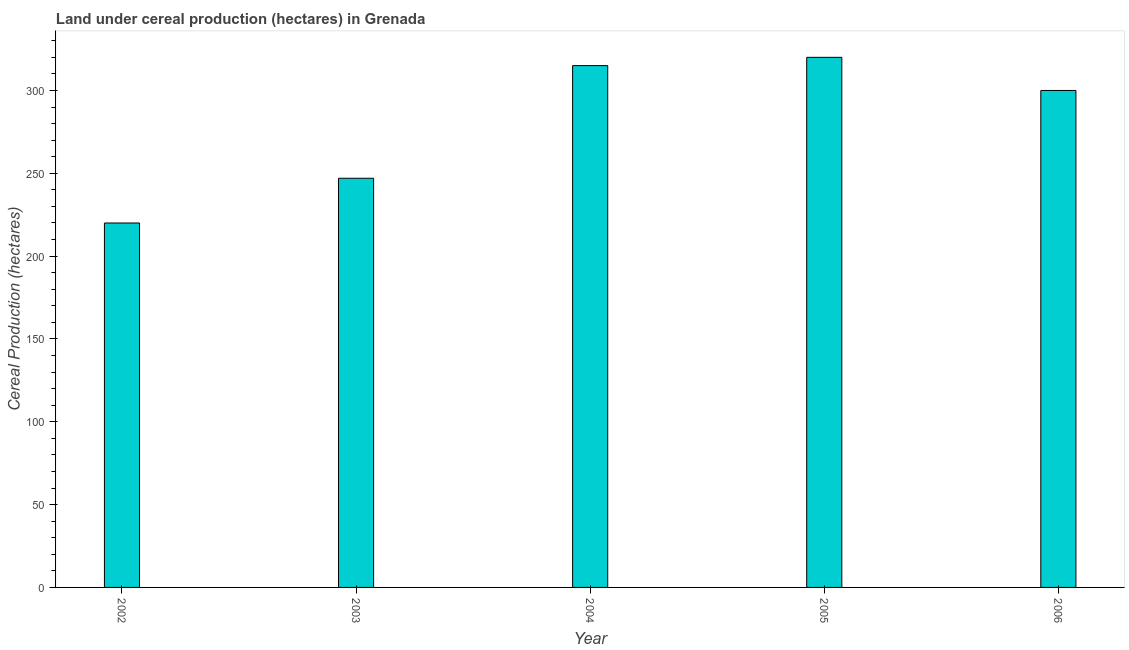Does the graph contain any zero values?
Offer a very short reply. No. What is the title of the graph?
Make the answer very short. Land under cereal production (hectares) in Grenada. What is the label or title of the Y-axis?
Provide a short and direct response. Cereal Production (hectares). What is the land under cereal production in 2006?
Provide a short and direct response. 300. Across all years, what is the maximum land under cereal production?
Ensure brevity in your answer.  320. Across all years, what is the minimum land under cereal production?
Ensure brevity in your answer.  220. What is the sum of the land under cereal production?
Your response must be concise. 1402. What is the difference between the land under cereal production in 2003 and 2004?
Your answer should be compact. -68. What is the average land under cereal production per year?
Provide a short and direct response. 280. What is the median land under cereal production?
Offer a very short reply. 300. Do a majority of the years between 2006 and 2005 (inclusive) have land under cereal production greater than 230 hectares?
Provide a succinct answer. No. What is the ratio of the land under cereal production in 2002 to that in 2006?
Your response must be concise. 0.73. Is the sum of the land under cereal production in 2004 and 2006 greater than the maximum land under cereal production across all years?
Give a very brief answer. Yes. What is the difference between the highest and the lowest land under cereal production?
Your response must be concise. 100. In how many years, is the land under cereal production greater than the average land under cereal production taken over all years?
Provide a succinct answer. 3. How many bars are there?
Ensure brevity in your answer.  5. Are all the bars in the graph horizontal?
Give a very brief answer. No. What is the Cereal Production (hectares) of 2002?
Your answer should be compact. 220. What is the Cereal Production (hectares) of 2003?
Ensure brevity in your answer.  247. What is the Cereal Production (hectares) in 2004?
Ensure brevity in your answer.  315. What is the Cereal Production (hectares) of 2005?
Provide a short and direct response. 320. What is the Cereal Production (hectares) in 2006?
Provide a succinct answer. 300. What is the difference between the Cereal Production (hectares) in 2002 and 2003?
Provide a succinct answer. -27. What is the difference between the Cereal Production (hectares) in 2002 and 2004?
Ensure brevity in your answer.  -95. What is the difference between the Cereal Production (hectares) in 2002 and 2005?
Ensure brevity in your answer.  -100. What is the difference between the Cereal Production (hectares) in 2002 and 2006?
Make the answer very short. -80. What is the difference between the Cereal Production (hectares) in 2003 and 2004?
Offer a terse response. -68. What is the difference between the Cereal Production (hectares) in 2003 and 2005?
Give a very brief answer. -73. What is the difference between the Cereal Production (hectares) in 2003 and 2006?
Give a very brief answer. -53. What is the ratio of the Cereal Production (hectares) in 2002 to that in 2003?
Make the answer very short. 0.89. What is the ratio of the Cereal Production (hectares) in 2002 to that in 2004?
Provide a succinct answer. 0.7. What is the ratio of the Cereal Production (hectares) in 2002 to that in 2005?
Offer a very short reply. 0.69. What is the ratio of the Cereal Production (hectares) in 2002 to that in 2006?
Keep it short and to the point. 0.73. What is the ratio of the Cereal Production (hectares) in 2003 to that in 2004?
Ensure brevity in your answer.  0.78. What is the ratio of the Cereal Production (hectares) in 2003 to that in 2005?
Your response must be concise. 0.77. What is the ratio of the Cereal Production (hectares) in 2003 to that in 2006?
Offer a very short reply. 0.82. What is the ratio of the Cereal Production (hectares) in 2004 to that in 2005?
Offer a terse response. 0.98. What is the ratio of the Cereal Production (hectares) in 2005 to that in 2006?
Your answer should be very brief. 1.07. 